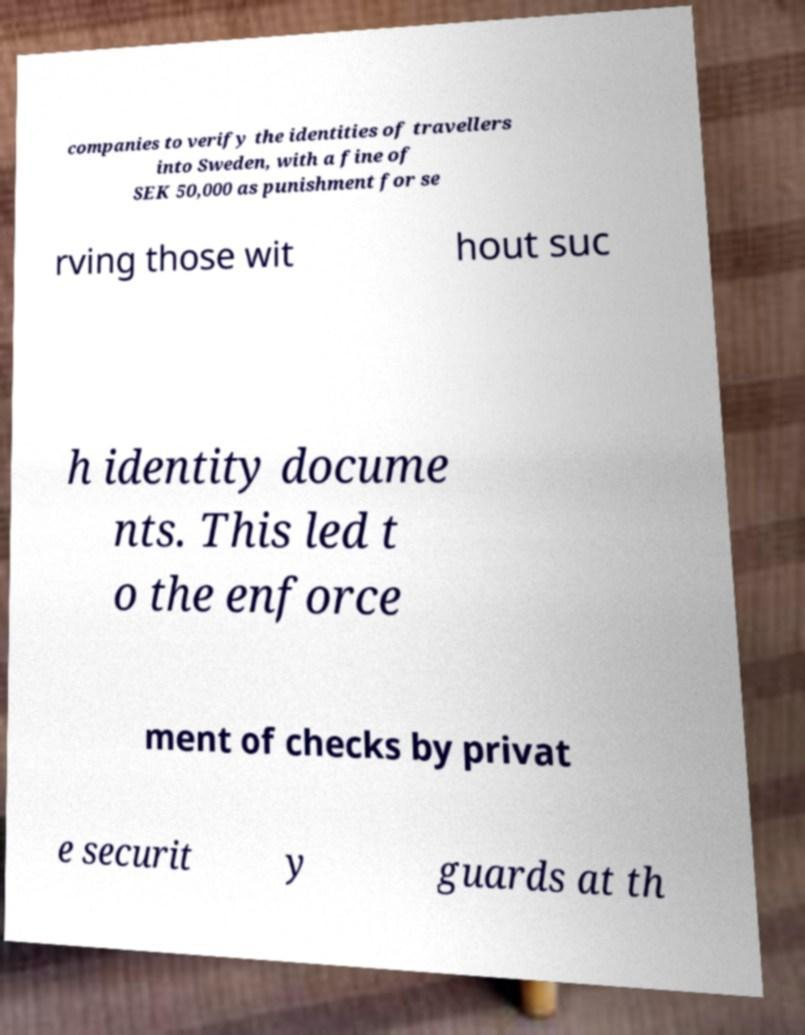Could you assist in decoding the text presented in this image and type it out clearly? companies to verify the identities of travellers into Sweden, with a fine of SEK 50,000 as punishment for se rving those wit hout suc h identity docume nts. This led t o the enforce ment of checks by privat e securit y guards at th 